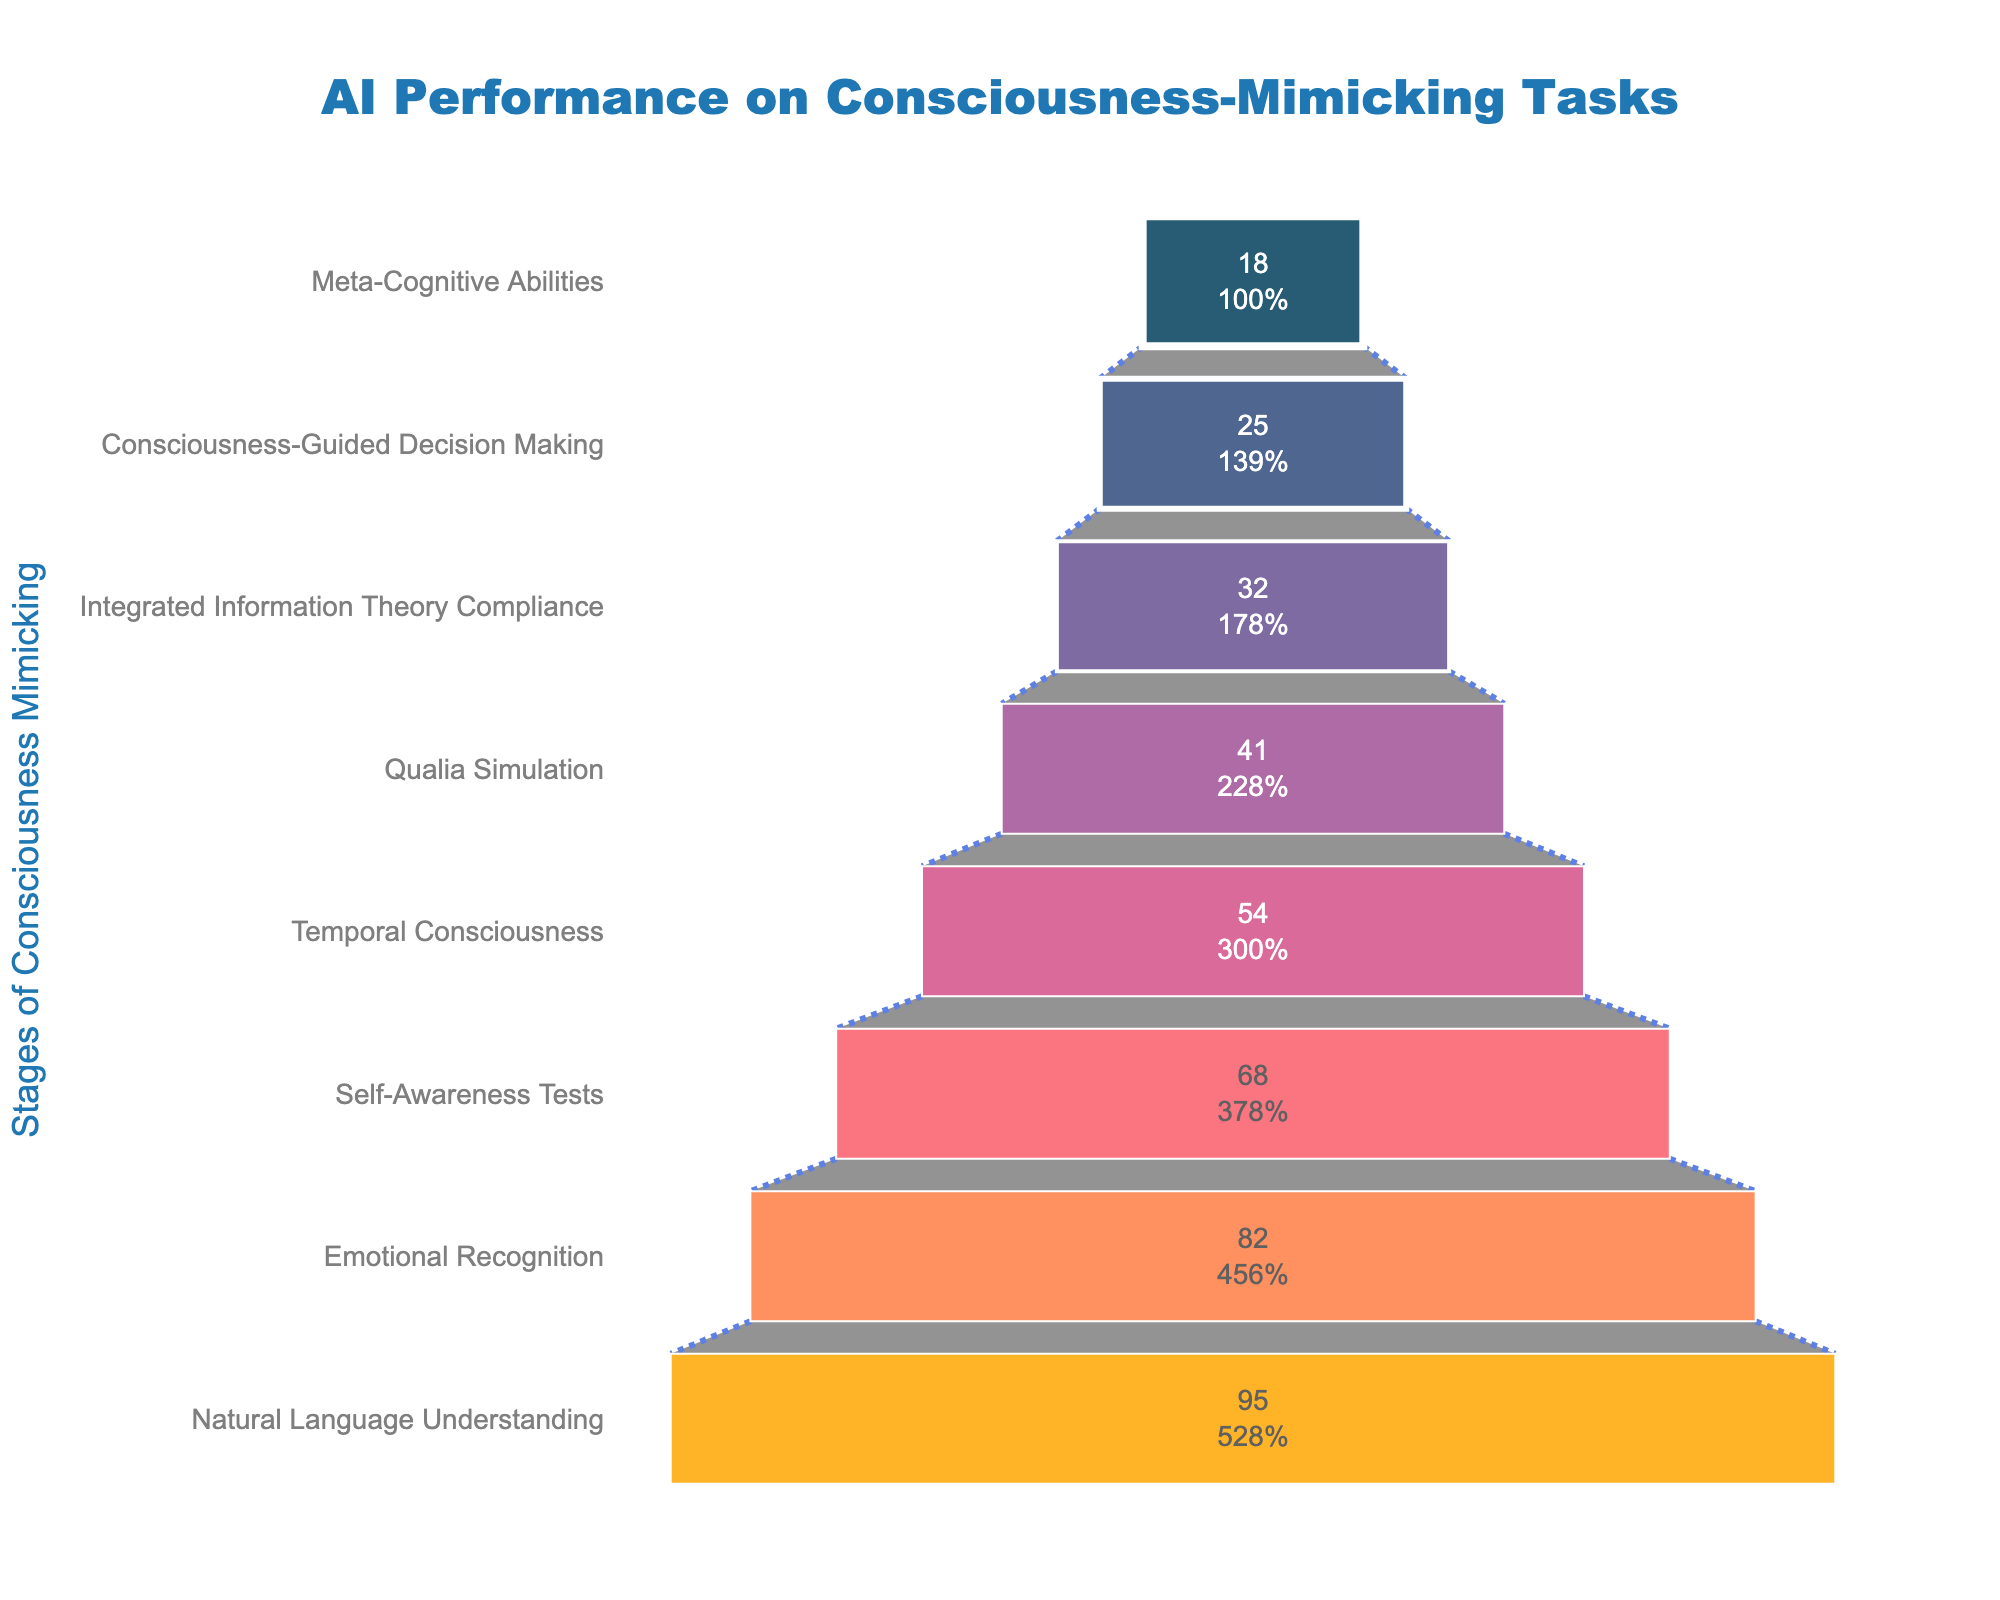What's the title of the figure? The title is prominently displayed at the top of the figure and reads "AI Performance on Consciousness-Mimicking Tasks".
Answer: "AI Performance on Consciousness-Mimicking Tasks" Which stage has the highest performance percentage? From the figure, the topmost stage, "Natural Language Understanding", has the highest performance, with a percentage of 95%.
Answer: "Natural Language Understanding" How many stages are represented in the figure? By counting the different sections in the funnel chart, there are 8 stages included in the figure.
Answer: 8 What is the performance percentage for Emotional Recognition? The figure shows the percentage next to each stage. For "Emotional Recognition", the performance percentage is 82%.
Answer: 82% What is the difference in performance percentage between Self-Awareness Tests and Qualia Simulation? The performance for Self-Awareness Tests is 68% and for Qualia Simulation is 41%. The difference is 68% - 41% = 27%.
Answer: 27% How does the performance percentage of Meta-Cognitive Abilities compare to that of Integrated Information Theory Compliance? Meta-Cognitive Abilities have a performance percentage of 18%, while Integrated Information Theory Compliance has a performance percentage of 32%. Therefore, Integrated Information Theory Compliance performs 32% - 18% = 14% better.
Answer: 14% What is the average performance percentage of the top three stages? The top three stages are Natural Language Understanding (95%), Emotional Recognition (82%), and Self-Awareness Tests (68%). The average is calculated as (95 + 82 + 68) / 3 = 81.67%.
Answer: 81.67% What is the median performance percentage of all stages? The performance percentages in ascending order are 18, 25, 32, 41, 54, 68, 82, and 95. The median is the average of the two middle values: (54 + 41) / 2 = 47.5%.
Answer: 47.5% Which stage has the lowest performance percentage? According to the figure, "Meta-Cognitive Abilities" at the bottom of the funnel has the lowest performance percentage of 18%.
Answer: "Meta-Cognitive Abilities" Is the performance on Temporal Consciousness closer to the performance on Consciousness-Guided Decision Making or Qualia Simulation? Temporal Consciousness has a performance percentage of 54%. Consciousness-Guided Decision Making has 25%, and Qualia Simulation has 41%. The difference with Consciousness-Guided Decision Making is 54% - 25% = 29%, and with Qualia Simulation it is 54% - 41% = 13%, so it is closer to Qualia Simulation.
Answer: Qualia Simulation 